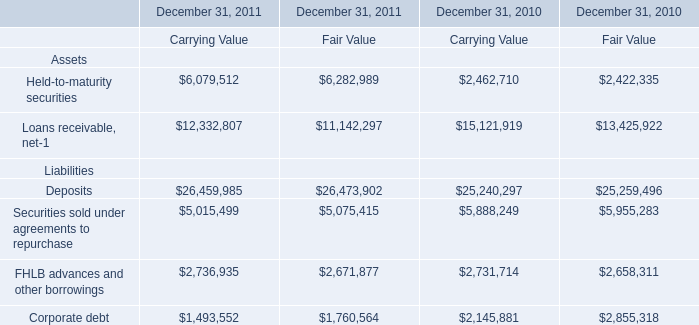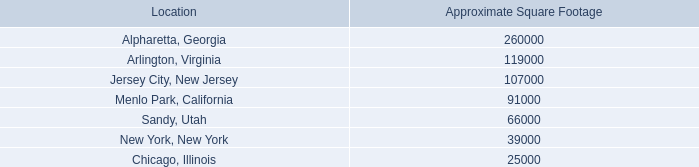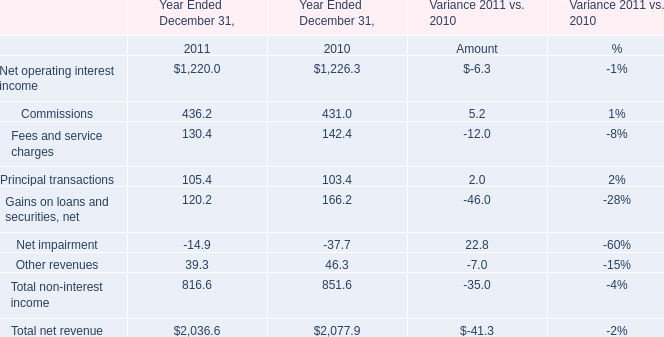What is the average amount of Loans receivable, net of December 31, 2011 Carrying Value, and Arlington, Virginia of Approximate Square Footage ? 
Computations: ((12332807.0 + 119000.0) / 2)
Answer: 6225903.5. 